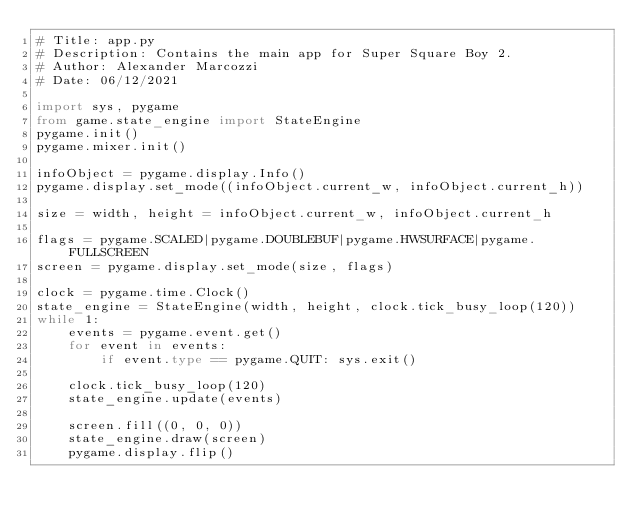<code> <loc_0><loc_0><loc_500><loc_500><_Python_># Title: app.py
# Description: Contains the main app for Super Square Boy 2.
# Author: Alexander Marcozzi
# Date: 06/12/2021

import sys, pygame
from game.state_engine import StateEngine
pygame.init()
pygame.mixer.init()

infoObject = pygame.display.Info()
pygame.display.set_mode((infoObject.current_w, infoObject.current_h))

size = width, height = infoObject.current_w, infoObject.current_h

flags = pygame.SCALED|pygame.DOUBLEBUF|pygame.HWSURFACE|pygame.FULLSCREEN
screen = pygame.display.set_mode(size, flags)

clock = pygame.time.Clock()
state_engine = StateEngine(width, height, clock.tick_busy_loop(120))
while 1:
    events = pygame.event.get()
    for event in events:
        if event.type == pygame.QUIT: sys.exit()

    clock.tick_busy_loop(120)
    state_engine.update(events)

    screen.fill((0, 0, 0))
    state_engine.draw(screen)
    pygame.display.flip()</code> 